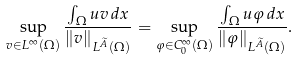Convert formula to latex. <formula><loc_0><loc_0><loc_500><loc_500>\sup _ { v \in L ^ { \infty } ( \Omega ) } \frac { \int _ { \Omega } u v \, d x } { \| v \| _ { L ^ { \widetilde { A } } ( \Omega ) } } = \sup _ { \varphi \in C ^ { \infty } _ { 0 } ( \Omega ) } \frac { \int _ { \Omega } u \varphi \, d x } { \| \varphi \| _ { L ^ { \widetilde { A } } ( \Omega ) } } .</formula> 